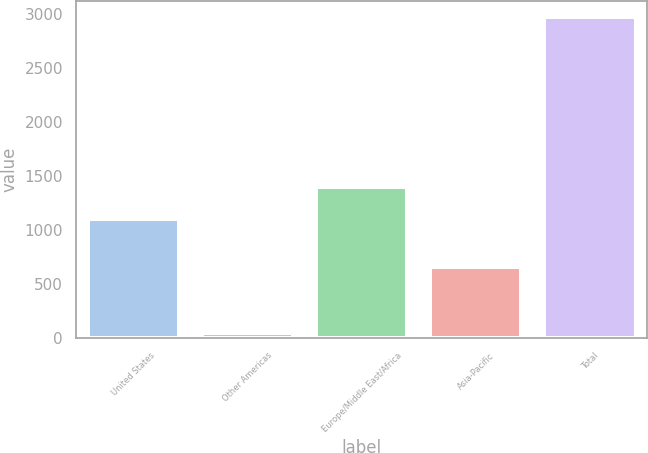Convert chart to OTSL. <chart><loc_0><loc_0><loc_500><loc_500><bar_chart><fcel>United States<fcel>Other Americas<fcel>Europe/Middle East/Africa<fcel>Asia-Pacific<fcel>Total<nl><fcel>1105<fcel>42<fcel>1398<fcel>659<fcel>2972<nl></chart> 